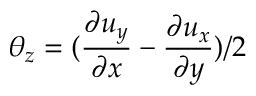<formula> <loc_0><loc_0><loc_500><loc_500>\theta _ { z } = ( \frac { \partial u _ { y } } { \partial x } - \frac { \partial u _ { x } } { \partial y } ) / 2</formula> 